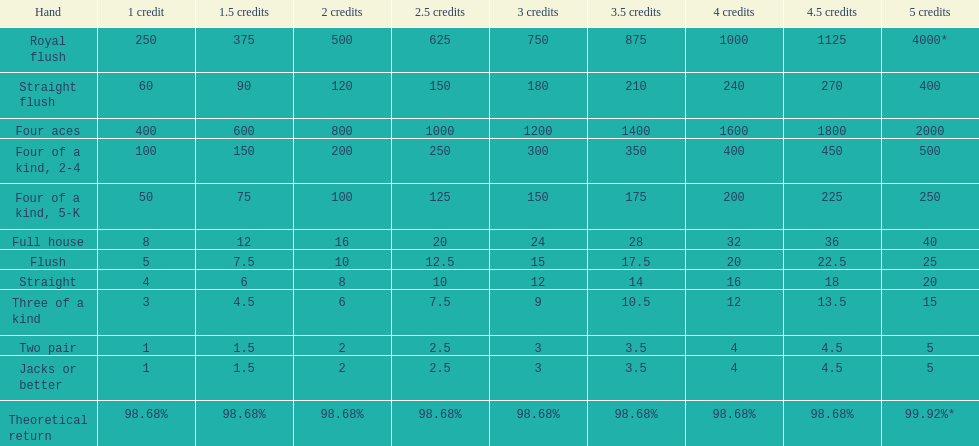How many credits do you have to spend to get at least 2000 in payout if you had four aces? 5 credits. 